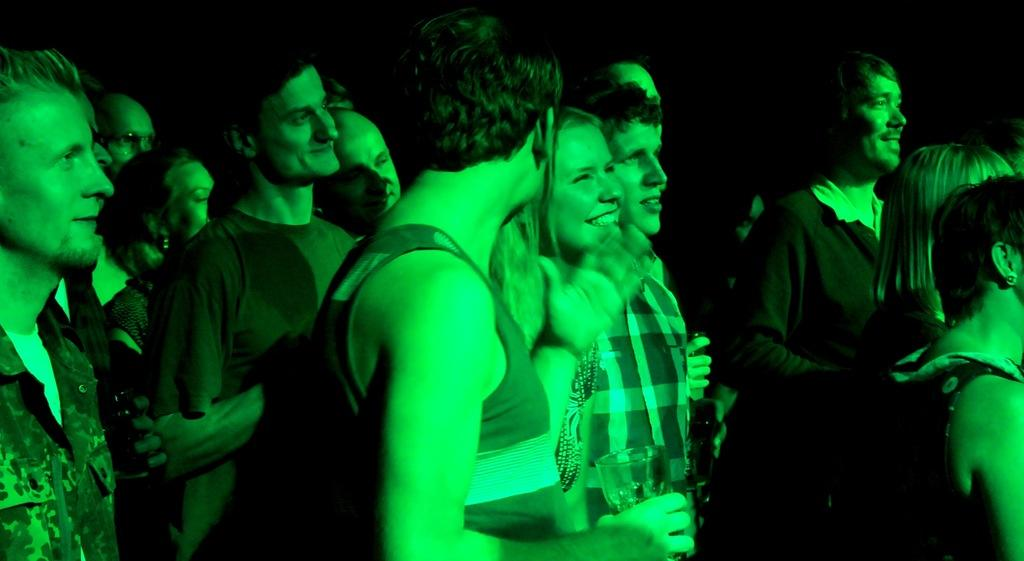What is the main subject of the image? The main subject of the image is a crowd of people. What are the people in the image doing? The people are standing and facing towards the right side. What is the mood of the people in the image? The people are smiling, which suggests a positive mood. What is the color of the background in the image? The background of the image is dark. How many eggs can be seen in the image? There are no eggs present in the image. What type of lizards are crawling on the people in the image? There are no lizards present in the image; the people are standing and facing towards the right side. 